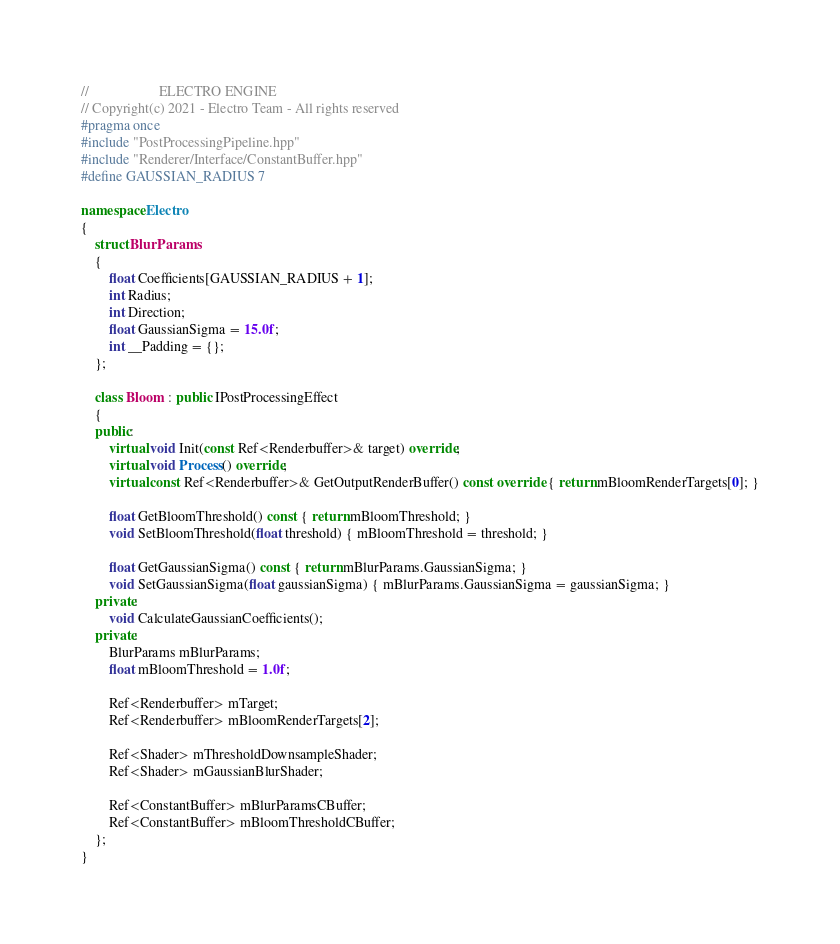<code> <loc_0><loc_0><loc_500><loc_500><_C++_>//                    ELECTRO ENGINE
// Copyright(c) 2021 - Electro Team - All rights reserved
#pragma once
#include "PostProcessingPipeline.hpp"
#include "Renderer/Interface/ConstantBuffer.hpp"
#define GAUSSIAN_RADIUS 7

namespace Electro
{
	struct BlurParams
	{
		float Coefficients[GAUSSIAN_RADIUS + 1];
		int Radius;
		int Direction;
		float GaussianSigma = 15.0f;
		int __Padding = {};
	};

	class Bloom : public IPostProcessingEffect
	{
	public:
		virtual void Init(const Ref<Renderbuffer>& target) override;
		virtual void Process() override;
		virtual const Ref<Renderbuffer>& GetOutputRenderBuffer() const override { return mBloomRenderTargets[0]; }

		float GetBloomThreshold() const { return mBloomThreshold; }
		void SetBloomThreshold(float threshold) { mBloomThreshold = threshold; }

		float GetGaussianSigma() const { return mBlurParams.GaussianSigma; }
		void SetGaussianSigma(float gaussianSigma) { mBlurParams.GaussianSigma = gaussianSigma; }
	private:
		void CalculateGaussianCoefficients();
	private:
		BlurParams mBlurParams;
		float mBloomThreshold = 1.0f;

		Ref<Renderbuffer> mTarget;
		Ref<Renderbuffer> mBloomRenderTargets[2];

		Ref<Shader> mThresholdDownsampleShader;
		Ref<Shader> mGaussianBlurShader;

		Ref<ConstantBuffer> mBlurParamsCBuffer;
		Ref<ConstantBuffer> mBloomThresholdCBuffer;
	};
}</code> 